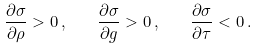Convert formula to latex. <formula><loc_0><loc_0><loc_500><loc_500>\frac { \partial \sigma } { \partial \rho } > 0 \, , \quad \frac { \partial \sigma } { \partial g } > 0 \, , \quad \frac { \partial \sigma } { \partial \tau } < 0 \, .</formula> 